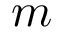Convert formula to latex. <formula><loc_0><loc_0><loc_500><loc_500>m</formula> 